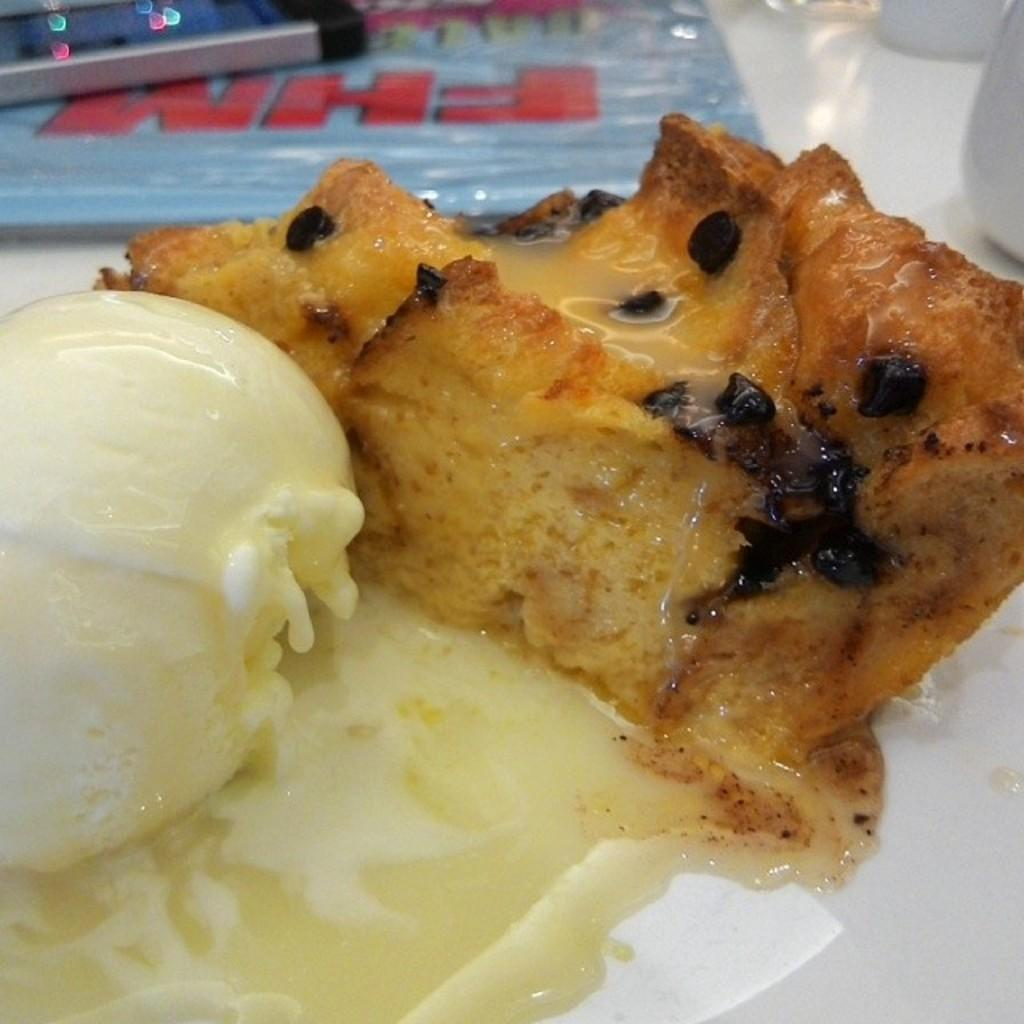What is the main utensil visible in the image? There is an ice-cream scoop in the image. What type of food is also present in the image? There is bread in the image. Where are the ice-cream scoop and bread located? The ice-cream scoop and bread are on a plate. On what surface is the plate placed? The plate is on a table. What other items can be seen near the plate? There are bowls to the right of the plate. What is the first object visible in the image? There is a sheet in the front of the image. What type of fiction is being read by the group in the image? There is no group or fiction present in the image; it only features an ice-cream scoop, bread, bowls, a plate, a table, and a sheet. 